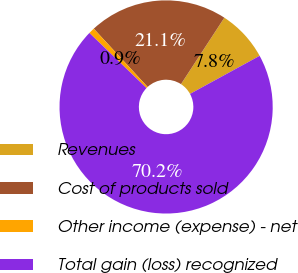<chart> <loc_0><loc_0><loc_500><loc_500><pie_chart><fcel>Revenues<fcel>Cost of products sold<fcel>Other income (expense) - net<fcel>Total gain (loss) recognized<nl><fcel>7.84%<fcel>21.08%<fcel>0.91%<fcel>70.18%<nl></chart> 